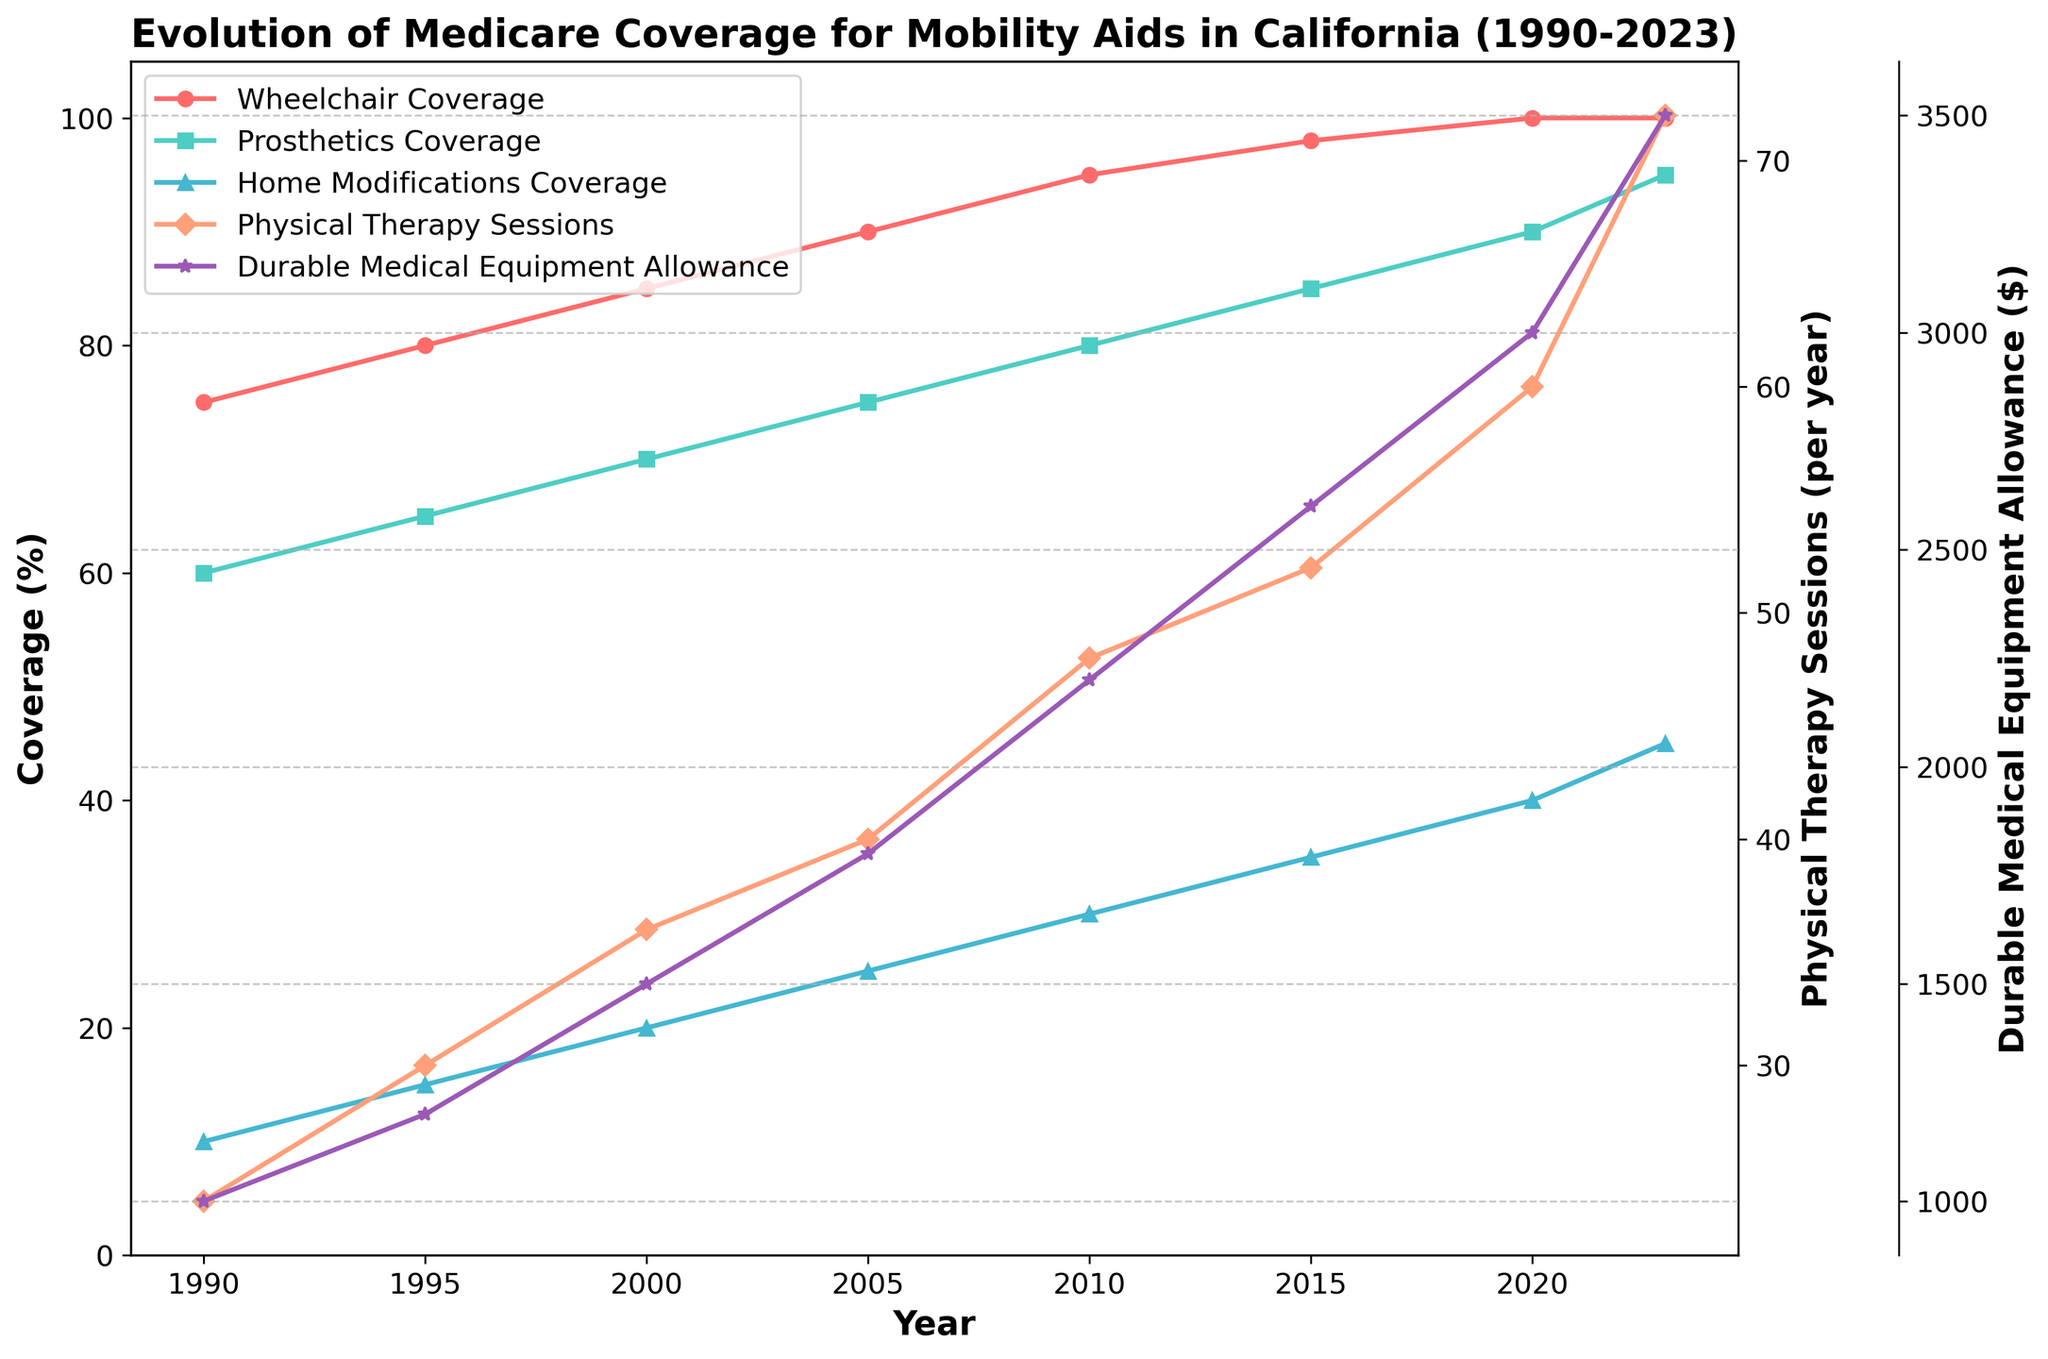Which year shows the highest increase in Durable Medical Equipment Allowance compared to the previous year? To find the highest increase, calculate the difference between consecutive years' Durable Medical Equipment Allowance and find the largest one. The differences are 200 (from 1990 to 1995), 300 (from 1995 to 2000), 300 (from 2000 to 2005), 400 (from 2005 to 2010), 400 (from 2010 to 2015), 400 (from 2015 to 2020), and 500 (from 2020 to 2023). Therefore, the highest increase is from 2020 to 2023.
Answer: 2020 to 2023 What is the trend in Wheelchair Coverage from 1990 to 2023? Look at the line representing Wheelchair Coverage. It consistently rises, starting at 75% in 1990 and reaching 100% in 2020, where it stabilizes until 2023.
Answer: Increasing Which year first saw 100% coverage for Wheelchairs? Find the year where the Wheelchair Coverage line hits 100%. This occurs first in 2020.
Answer: 2020 By how much did Physical Therapy Sessions increase from 1990 to 2023? Subtract the number of Physical Therapy Sessions in 1990 (24) from the number in 2023 (72). 72 - 24 = 48.
Answer: 48 Compare the Home Modifications Coverage and Prosthetics Coverage in 2010. Which is higher and by how much? In 2010, Home Modifications Coverage is at 30%, and Prosthetics Coverage is 80%. Subtract Home Modifications Coverage from Prosthetics Coverage: 80% - 30% = 50%.
Answer: Prosthetics by 50% Which type of coverage showed the most consistent increase over the years? Check the lines on the graph to see which shows a steady rise. All lines show a rising trend, but Wheelchair Coverage increases consistently at a similar rate across the years.
Answer: Wheelchair Coverage What is the difference between the highest and lowest Durable Medical Equipment Allowance values? Find the highest value ($3500 in 2023) and the lowest value ($1000 in 1990), then compute the difference: 3500 - 1000 = 2500.
Answer: 2500 